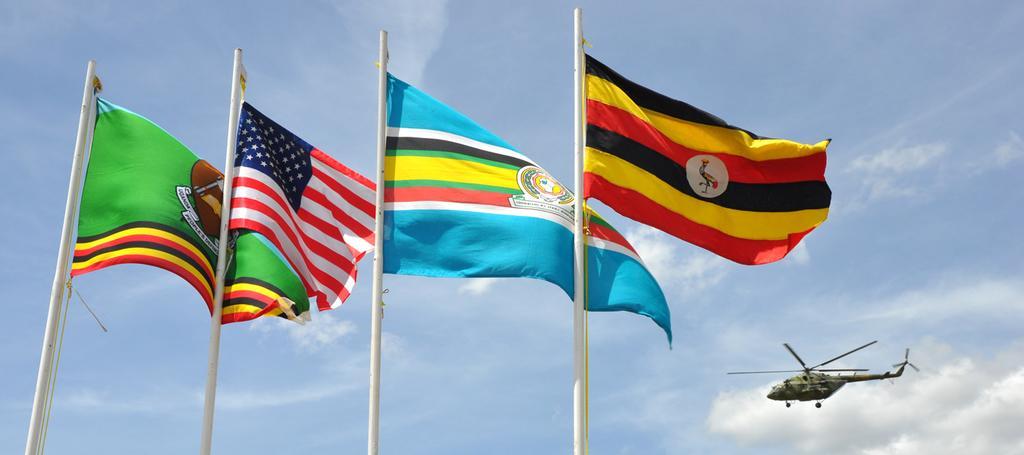In one or two sentences, can you explain what this image depicts? In this image in the foreground there are some poles and flags, and on the right side there is a helicopter. In the background there is sky. 